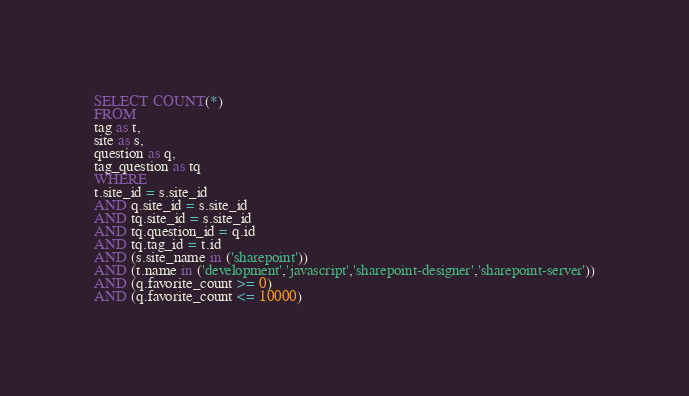Convert code to text. <code><loc_0><loc_0><loc_500><loc_500><_SQL_>SELECT COUNT(*)
FROM
tag as t,
site as s,
question as q,
tag_question as tq
WHERE
t.site_id = s.site_id
AND q.site_id = s.site_id
AND tq.site_id = s.site_id
AND tq.question_id = q.id
AND tq.tag_id = t.id
AND (s.site_name in ('sharepoint'))
AND (t.name in ('development','javascript','sharepoint-designer','sharepoint-server'))
AND (q.favorite_count >= 0)
AND (q.favorite_count <= 10000)
</code> 